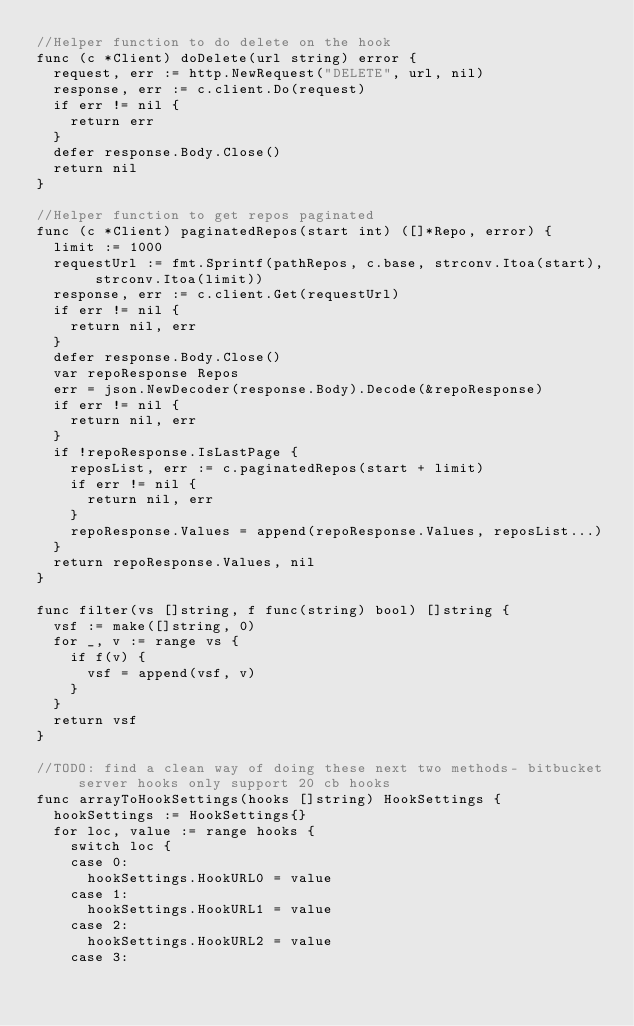Convert code to text. <code><loc_0><loc_0><loc_500><loc_500><_Go_>//Helper function to do delete on the hook
func (c *Client) doDelete(url string) error {
	request, err := http.NewRequest("DELETE", url, nil)
	response, err := c.client.Do(request)
	if err != nil {
		return err
	}
	defer response.Body.Close()
	return nil
}

//Helper function to get repos paginated
func (c *Client) paginatedRepos(start int) ([]*Repo, error) {
	limit := 1000
	requestUrl := fmt.Sprintf(pathRepos, c.base, strconv.Itoa(start), strconv.Itoa(limit))
	response, err := c.client.Get(requestUrl)
	if err != nil {
		return nil, err
	}
	defer response.Body.Close()
	var repoResponse Repos
	err = json.NewDecoder(response.Body).Decode(&repoResponse)
	if err != nil {
		return nil, err
	}
	if !repoResponse.IsLastPage {
		reposList, err := c.paginatedRepos(start + limit)
		if err != nil {
			return nil, err
		}
		repoResponse.Values = append(repoResponse.Values, reposList...)
	}
	return repoResponse.Values, nil
}

func filter(vs []string, f func(string) bool) []string {
	vsf := make([]string, 0)
	for _, v := range vs {
		if f(v) {
			vsf = append(vsf, v)
		}
	}
	return vsf
}

//TODO: find a clean way of doing these next two methods- bitbucket server hooks only support 20 cb hooks
func arrayToHookSettings(hooks []string) HookSettings {
	hookSettings := HookSettings{}
	for loc, value := range hooks {
		switch loc {
		case 0:
			hookSettings.HookURL0 = value
		case 1:
			hookSettings.HookURL1 = value
		case 2:
			hookSettings.HookURL2 = value
		case 3:</code> 